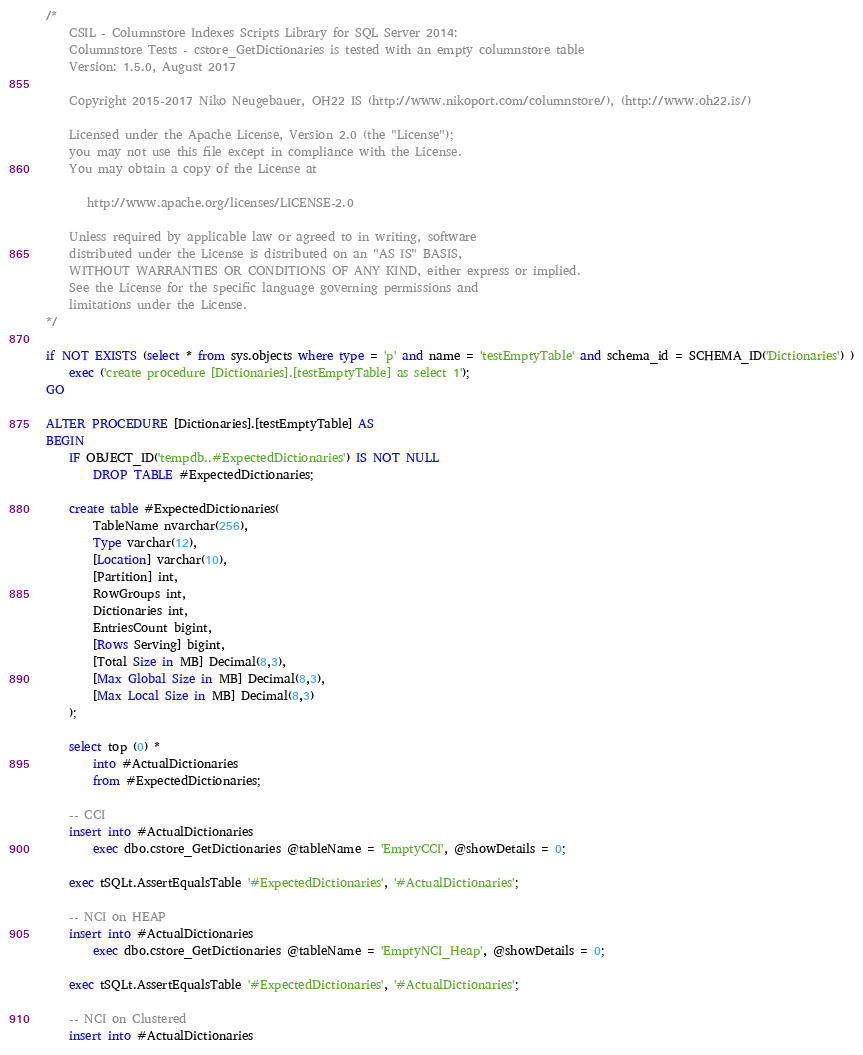Convert code to text. <code><loc_0><loc_0><loc_500><loc_500><_SQL_>/*
	CSIL - Columnstore Indexes Scripts Library for SQL Server 2014: 
	Columnstore Tests - cstore_GetDictionaries is tested with an empty columnstore table 
	Version: 1.5.0, August 2017

	Copyright 2015-2017 Niko Neugebauer, OH22 IS (http://www.nikoport.com/columnstore/), (http://www.oh22.is/)

	Licensed under the Apache License, Version 2.0 (the "License");
	you may not use this file except in compliance with the License.
	You may obtain a copy of the License at

       http://www.apache.org/licenses/LICENSE-2.0

    Unless required by applicable law or agreed to in writing, software
    distributed under the License is distributed on an "AS IS" BASIS,
    WITHOUT WARRANTIES OR CONDITIONS OF ANY KIND, either express or implied.
    See the License for the specific language governing permissions and
    limitations under the License.
*/

if NOT EXISTS (select * from sys.objects where type = 'p' and name = 'testEmptyTable' and schema_id = SCHEMA_ID('Dictionaries') )
	exec ('create procedure [Dictionaries].[testEmptyTable] as select 1');
GO

ALTER PROCEDURE [Dictionaries].[testEmptyTable] AS
BEGIN
	IF OBJECT_ID('tempdb..#ExpectedDictionaries') IS NOT NULL
		DROP TABLE #ExpectedDictionaries;

	create table #ExpectedDictionaries(
		TableName nvarchar(256),
		Type varchar(12),
		[Location] varchar(10),			
		[Partition] int,
		RowGroups int,
		Dictionaries int,
		EntriesCount bigint,
		[Rows Serving] bigint,
		[Total Size in MB] Decimal(8,3),
		[Max Global Size in MB] Decimal(8,3),
		[Max Local Size in MB] Decimal(8,3)
	);

	select top (0) *
		into #ActualDictionaries
		from #ExpectedDictionaries;

	-- CCI
	insert into #ActualDictionaries
		exec dbo.cstore_GetDictionaries @tableName = 'EmptyCCI', @showDetails = 0;

	exec tSQLt.AssertEqualsTable '#ExpectedDictionaries', '#ActualDictionaries';

	-- NCI on HEAP
	insert into #ActualDictionaries
		exec dbo.cstore_GetDictionaries @tableName = 'EmptyNCI_Heap', @showDetails = 0;

	exec tSQLt.AssertEqualsTable '#ExpectedDictionaries', '#ActualDictionaries';

	-- NCI on Clustered
	insert into #ActualDictionaries</code> 